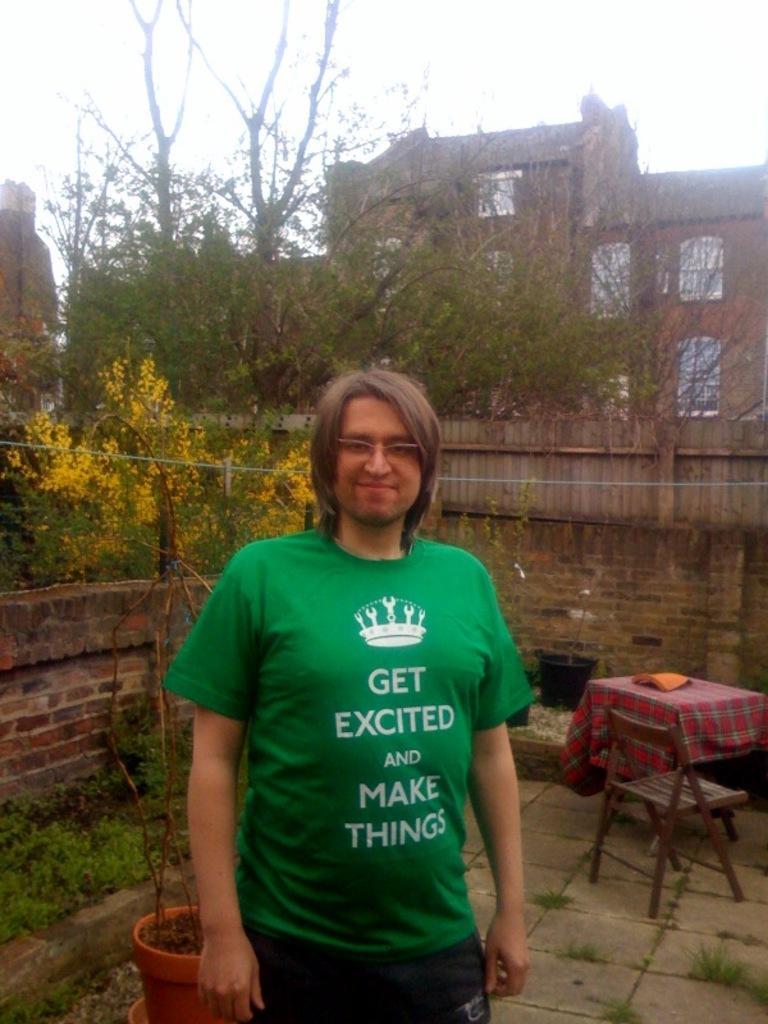In one or two sentences, can you explain what this image depicts? This picture shows a man standing with a smile on his face and we see few houses on his back and few plants and a table 